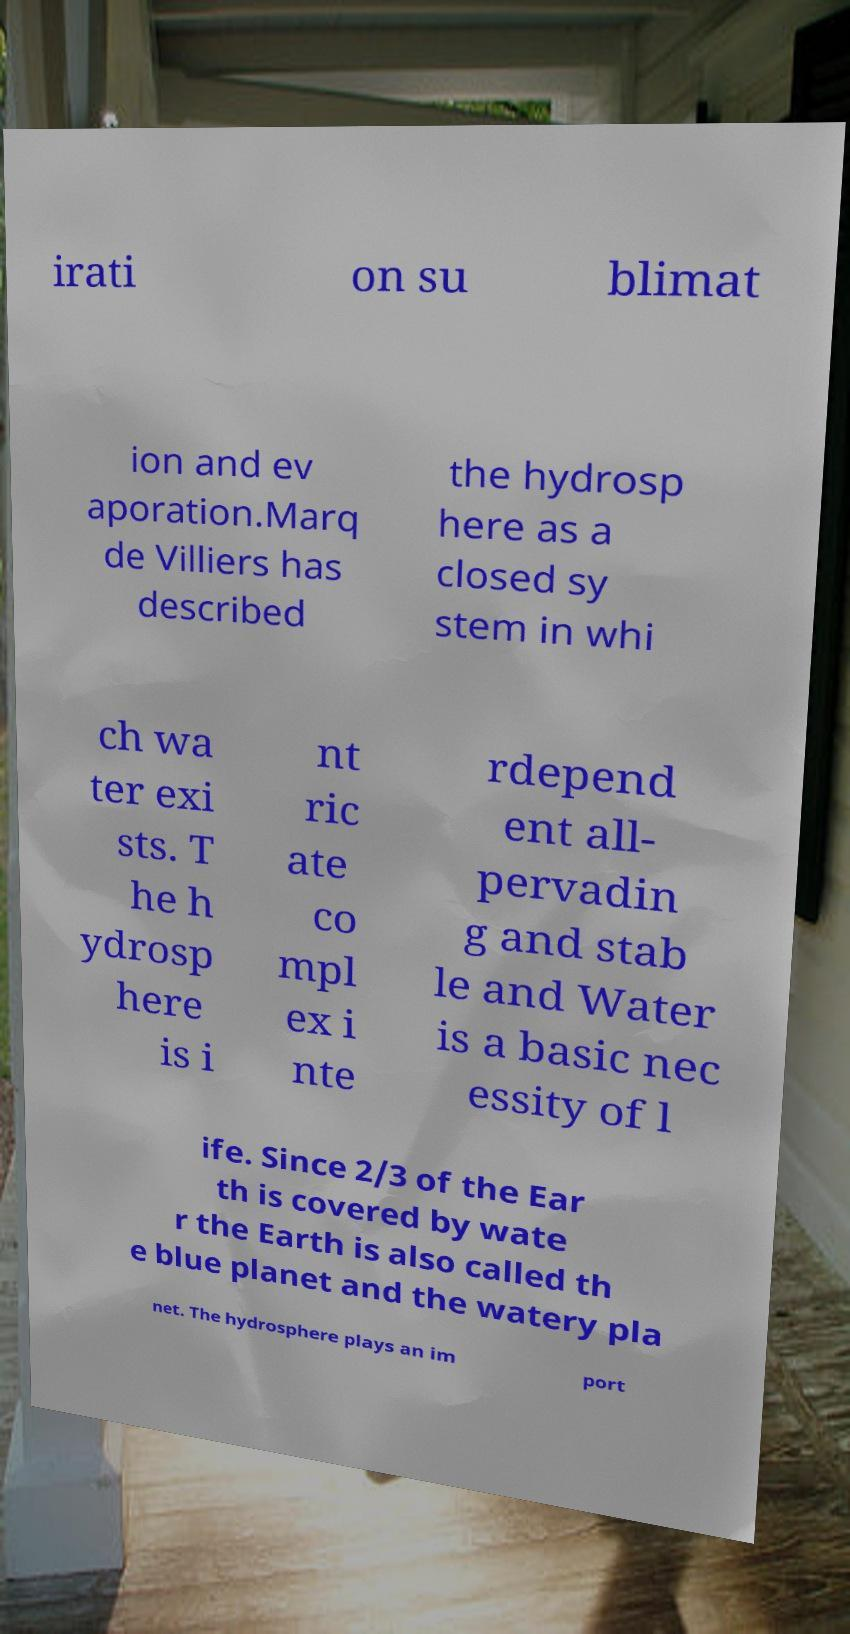Can you accurately transcribe the text from the provided image for me? irati on su blimat ion and ev aporation.Marq de Villiers has described the hydrosp here as a closed sy stem in whi ch wa ter exi sts. T he h ydrosp here is i nt ric ate co mpl ex i nte rdepend ent all- pervadin g and stab le and Water is a basic nec essity of l ife. Since 2/3 of the Ear th is covered by wate r the Earth is also called th e blue planet and the watery pla net. The hydrosphere plays an im port 